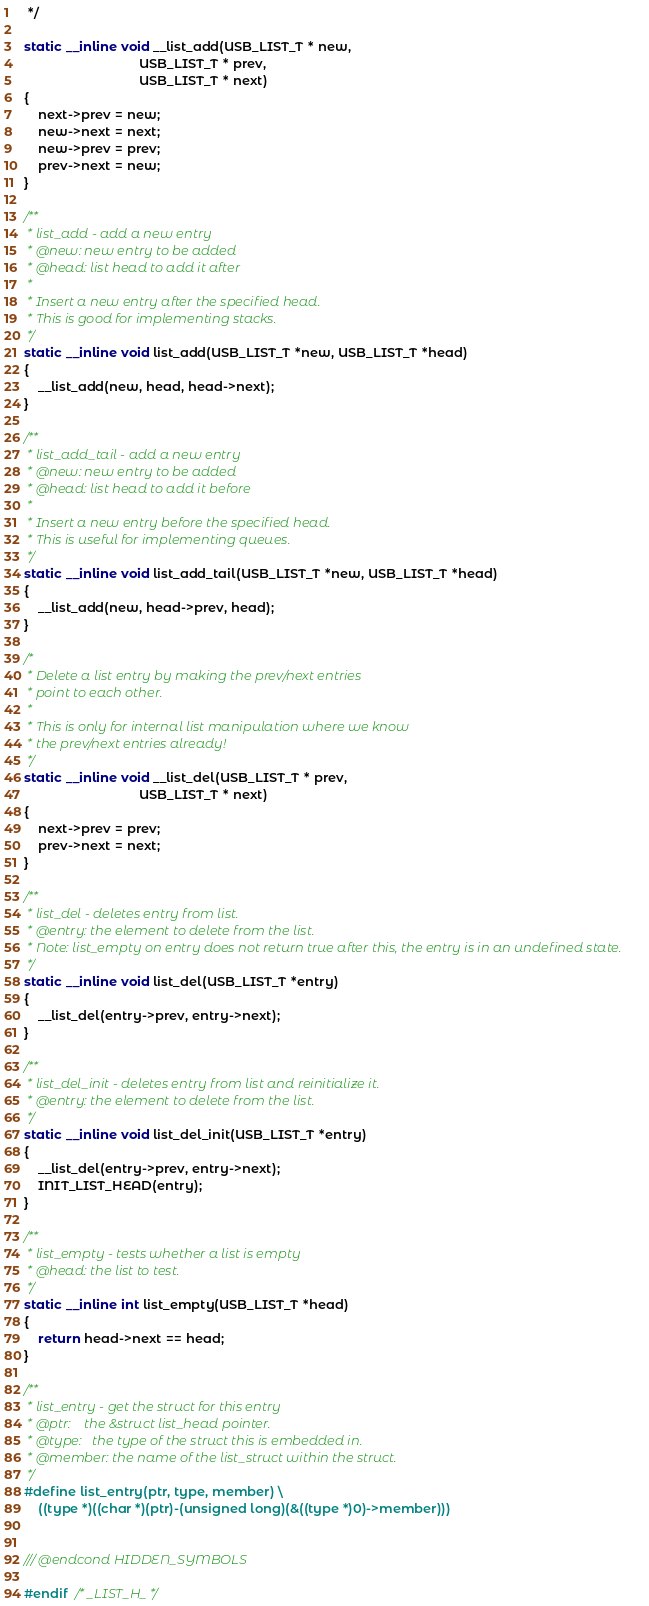<code> <loc_0><loc_0><loc_500><loc_500><_C_> */

static __inline void __list_add(USB_LIST_T * new,
                                USB_LIST_T * prev,
                                USB_LIST_T * next)
{
    next->prev = new;
    new->next = next;
    new->prev = prev;
    prev->next = new;
}

/**
 * list_add - add a new entry
 * @new: new entry to be added
 * @head: list head to add it after
 *
 * Insert a new entry after the specified head.
 * This is good for implementing stacks.
 */
static __inline void list_add(USB_LIST_T *new, USB_LIST_T *head)
{
    __list_add(new, head, head->next);
}

/**
 * list_add_tail - add a new entry
 * @new: new entry to be added
 * @head: list head to add it before
 *
 * Insert a new entry before the specified head.
 * This is useful for implementing queues.
 */
static __inline void list_add_tail(USB_LIST_T *new, USB_LIST_T *head)
{
    __list_add(new, head->prev, head);
}

/*
 * Delete a list entry by making the prev/next entries
 * point to each other.
 *
 * This is only for internal list manipulation where we know
 * the prev/next entries already!
 */
static __inline void __list_del(USB_LIST_T * prev,
                                USB_LIST_T * next)
{
    next->prev = prev;
    prev->next = next;
}

/**
 * list_del - deletes entry from list.
 * @entry: the element to delete from the list.
 * Note: list_empty on entry does not return true after this, the entry is in an undefined state.
 */
static __inline void list_del(USB_LIST_T *entry)
{
    __list_del(entry->prev, entry->next);
}

/**
 * list_del_init - deletes entry from list and reinitialize it.
 * @entry: the element to delete from the list.
 */
static __inline void list_del_init(USB_LIST_T *entry)
{
    __list_del(entry->prev, entry->next);
    INIT_LIST_HEAD(entry);
}

/**
 * list_empty - tests whether a list is empty
 * @head: the list to test.
 */
static __inline int list_empty(USB_LIST_T *head)
{
    return head->next == head;
}

/**
 * list_entry - get the struct for this entry
 * @ptr:    the &struct list_head pointer.
 * @type:   the type of the struct this is embedded in.
 * @member: the name of the list_struct within the struct.
 */
#define list_entry(ptr, type, member) \
    ((type *)((char *)(ptr)-(unsigned long)(&((type *)0)->member)))


/// @endcond HIDDEN_SYMBOLS

#endif  /* _LIST_H_ */
</code> 